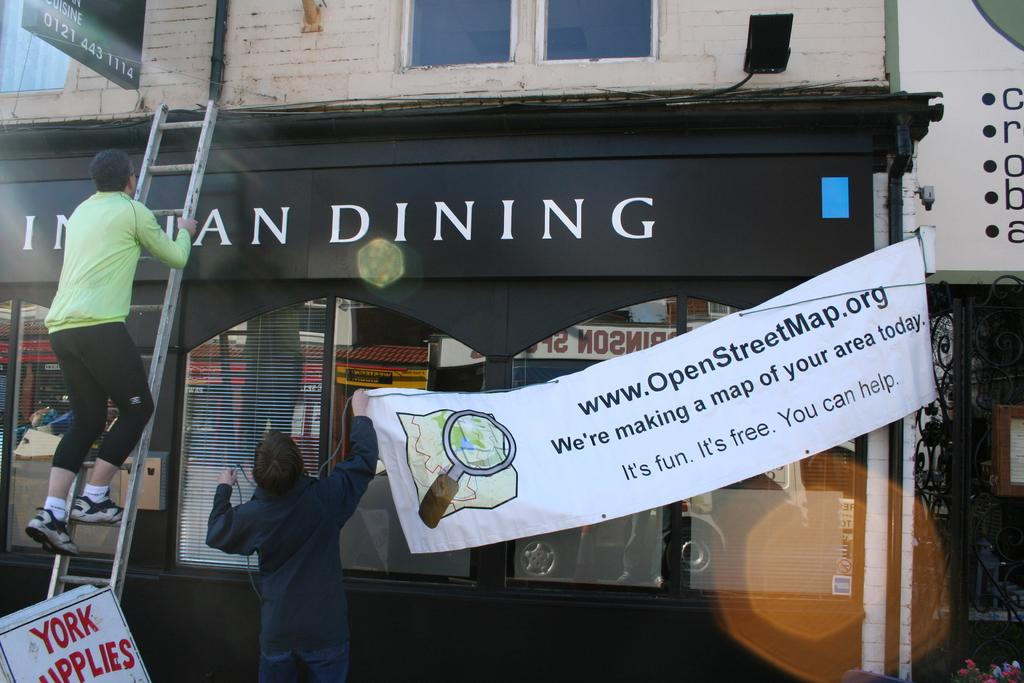What is the main structure in the center of the image? There is a building in the center of the image. What is hanging in the center of the image? There is a banner in the center of the image. What activity is being performed on the left side of the image? There is a person climbing a ladder on the left side of the image. Where is the waste being disposed of at the seashore in the image? There is no seashore or waste present in the image. What statement is being made by the person climbing the ladder in the image? There is no statement being made by the person climbing the ladder in the image; they are simply performing an activity. 